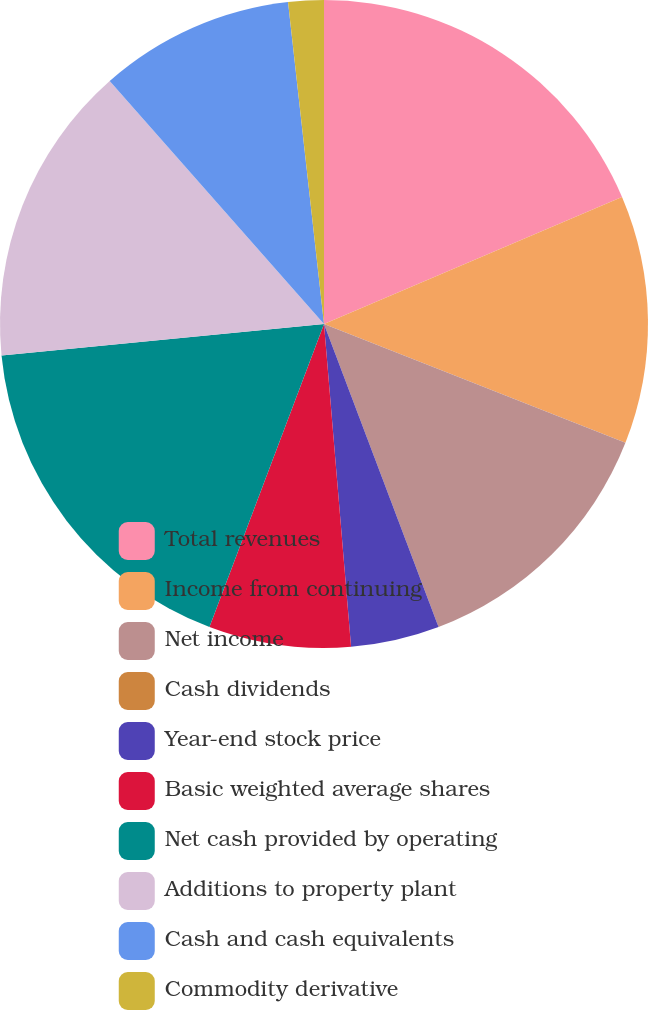Convert chart to OTSL. <chart><loc_0><loc_0><loc_500><loc_500><pie_chart><fcel>Total revenues<fcel>Income from continuing<fcel>Net income<fcel>Cash dividends<fcel>Year-end stock price<fcel>Basic weighted average shares<fcel>Net cash provided by operating<fcel>Additions to property plant<fcel>Cash and cash equivalents<fcel>Commodity derivative<nl><fcel>18.58%<fcel>12.39%<fcel>13.27%<fcel>0.0%<fcel>4.42%<fcel>7.08%<fcel>17.7%<fcel>15.04%<fcel>9.73%<fcel>1.77%<nl></chart> 